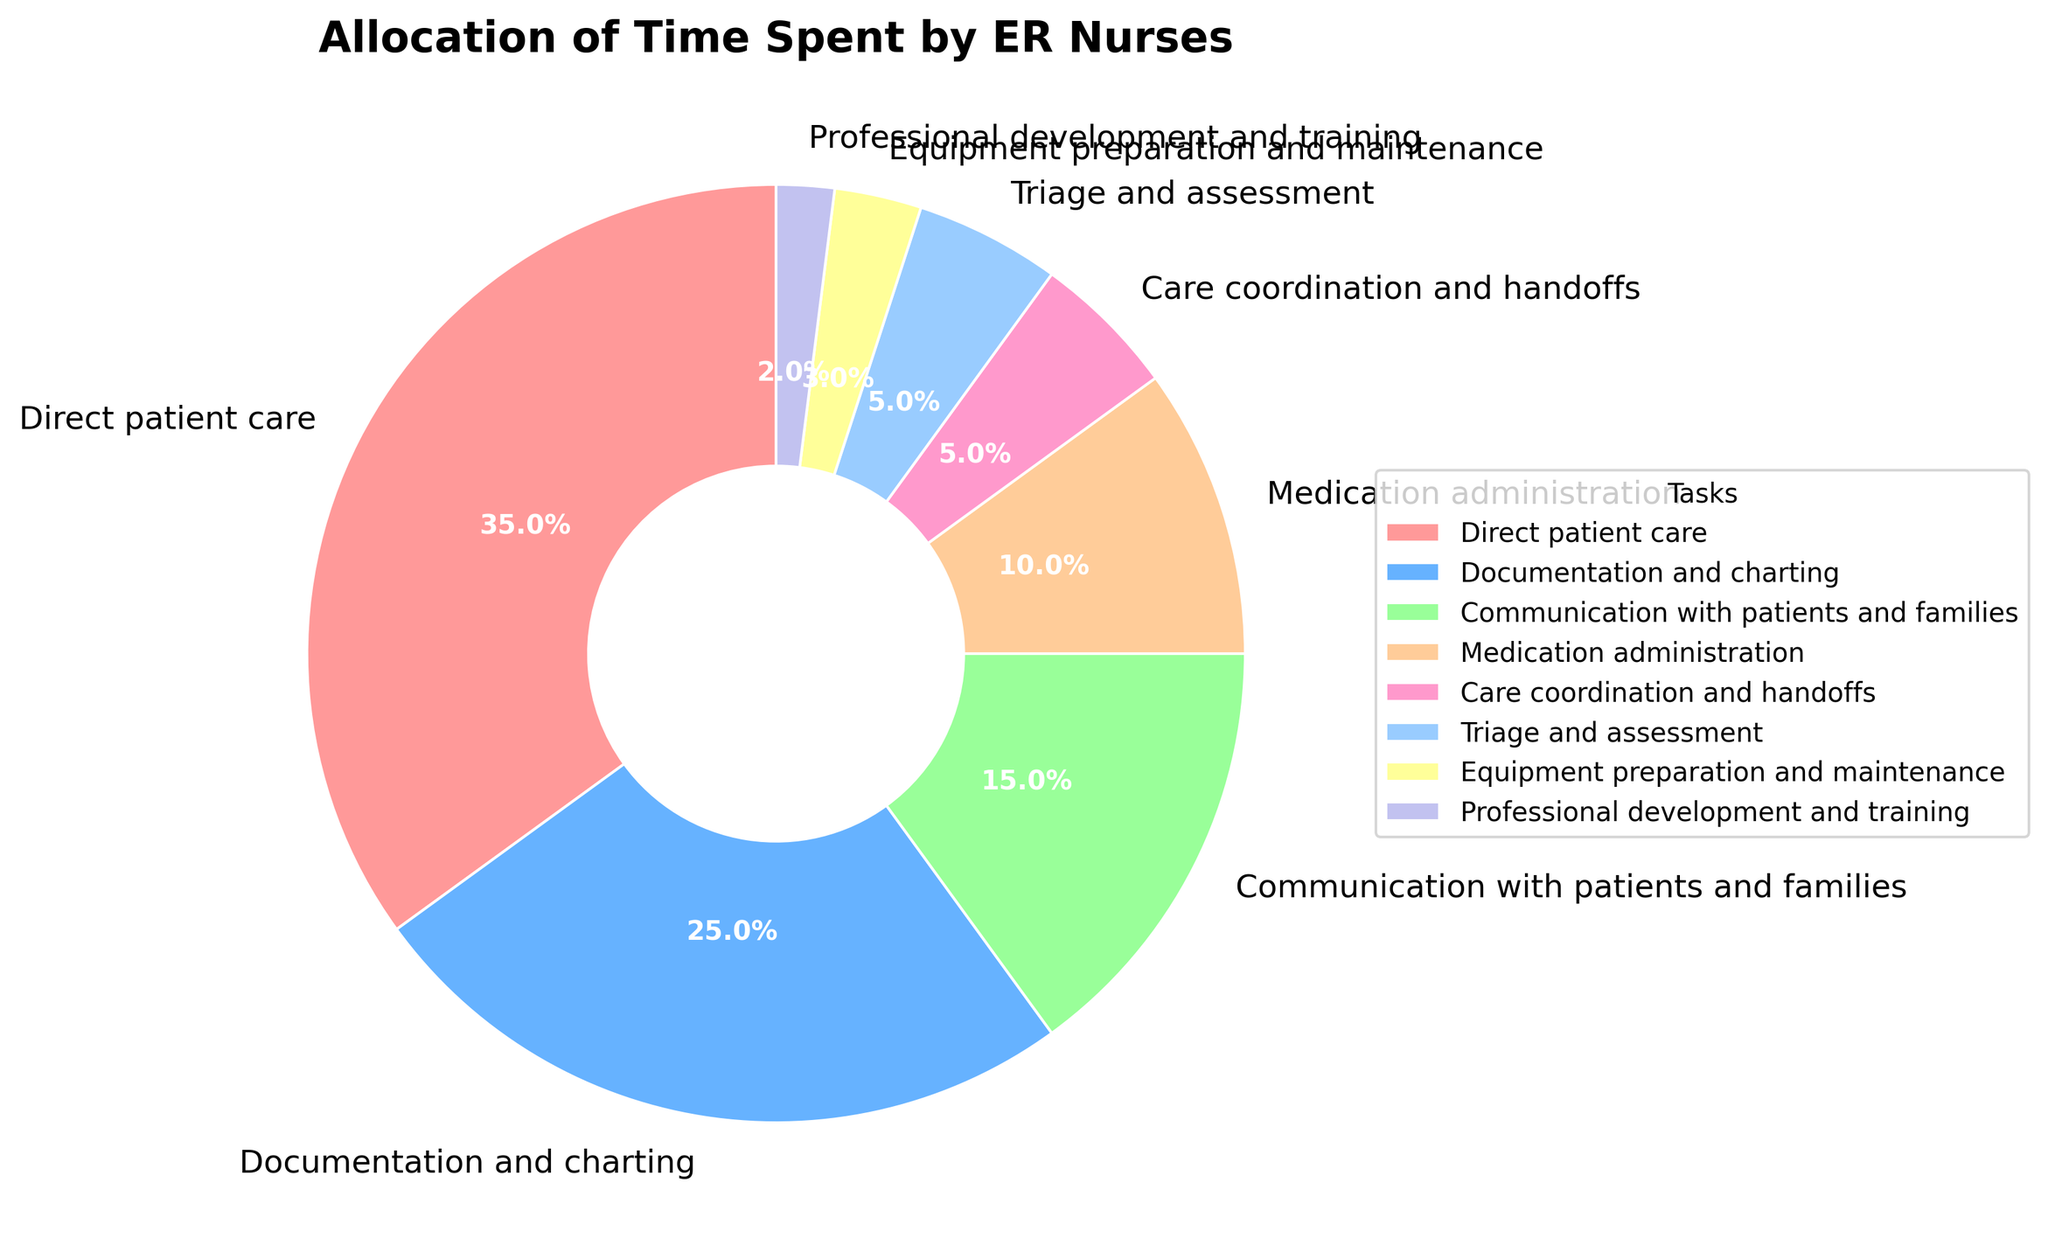What task occupies the largest proportion of time for ER nurses? Direct patient care occupies the largest proportion of the ER nurses' time as indicated by the largest slice of the pie chart.
Answer: Direct patient care What percentage of time do ER nurses spend on tasks related to documentation and charting combined with communication with patients and families? The slice for documentation and charting shows 25%, and the slice for communication with patients and families shows 15%. Adding these percentages gives 25% + 15% = 40%.
Answer: 40% Which task has the smallest allocation percentage? The smallest slice of the pie chart is labeled for professional development and training, which has 2%.
Answer: Professional development and training Are ER nurses spending more time on medication administration or on care coordination and handoffs? The slice for medication administration is 10%, and the slice for care coordination and handoffs is 5%. Comparing the two, 10% is greater than 5%.
Answer: Medication administration What are the combined percentages for equipment preparation and maintenance and professional development and training? The slice for equipment preparation and maintenance indicates 3%, and the slice for professional development and training indicates 2%. Adding these together results in 3% + 2% = 5%.
Answer: 5% Is the time spent on triage and assessment equal to the time spent on care coordination and handoffs? The slice for triage and assessment is labeled as 5%, and the slice for care coordination and handoffs is also labeled as 5%. Thus, the time spent on both tasks is equal.
Answer: Yes How much more time do ER nurses spend on triage and assessment compared to equipment preparation and maintenance? The slice for triage and assessment shows 5%, while equipment preparation and maintenance shows 3%. The difference between these values is 5% - 3% = 2%.
Answer: 2% Which visual attribute allows you to quickly identify the task with the second-largest allocation of time? The second-largest slice on the pie chart visually indicates the task with the second-largest allocation of time. This slice corresponds to documentation and charting at 25%.
Answer: The slice size What is the combined percentage of time spent on direct patient care, medication administration, and care coordination and handoffs? The slices show 35% for direct patient care, 10% for medication administration, and 5% for care coordination and handoffs. Adding these percentages results in 35% + 10% + 5% = 50%.
Answer: 50% Do ER nurses spend more than 30% of their time on non-patient care tasks? Non-patient care tasks include documentation, communication, medication administration, care coordination and handoffs, triage and assessment, equipment preparation, and professional development. Adding these segments gives 25% + 15% + 10% + 5% + 5% + 3% + 2% = 65%, which is more than 30%.
Answer: Yes 